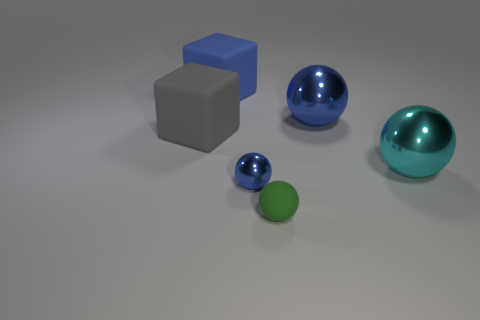What is the material of the big blue object right of the tiny ball behind the small green ball?
Your response must be concise. Metal. Are there any big blocks of the same color as the small shiny sphere?
Ensure brevity in your answer.  Yes. Do the small metallic object and the ball behind the cyan object have the same color?
Offer a very short reply. Yes. Is there a cyan object made of the same material as the big cyan ball?
Provide a succinct answer. No. There is a small matte object that is the same shape as the tiny blue shiny thing; what color is it?
Your response must be concise. Green. Is the number of small blue things that are to the right of the green object less than the number of big matte objects that are behind the large gray thing?
Make the answer very short. Yes. How many other things are the same shape as the cyan thing?
Provide a short and direct response. 3. Are there fewer blue objects to the right of the cyan object than big red metallic spheres?
Give a very brief answer. No. There is a blue object left of the small blue shiny object; what is it made of?
Offer a very short reply. Rubber. How many other objects are there of the same size as the rubber sphere?
Ensure brevity in your answer.  1. 